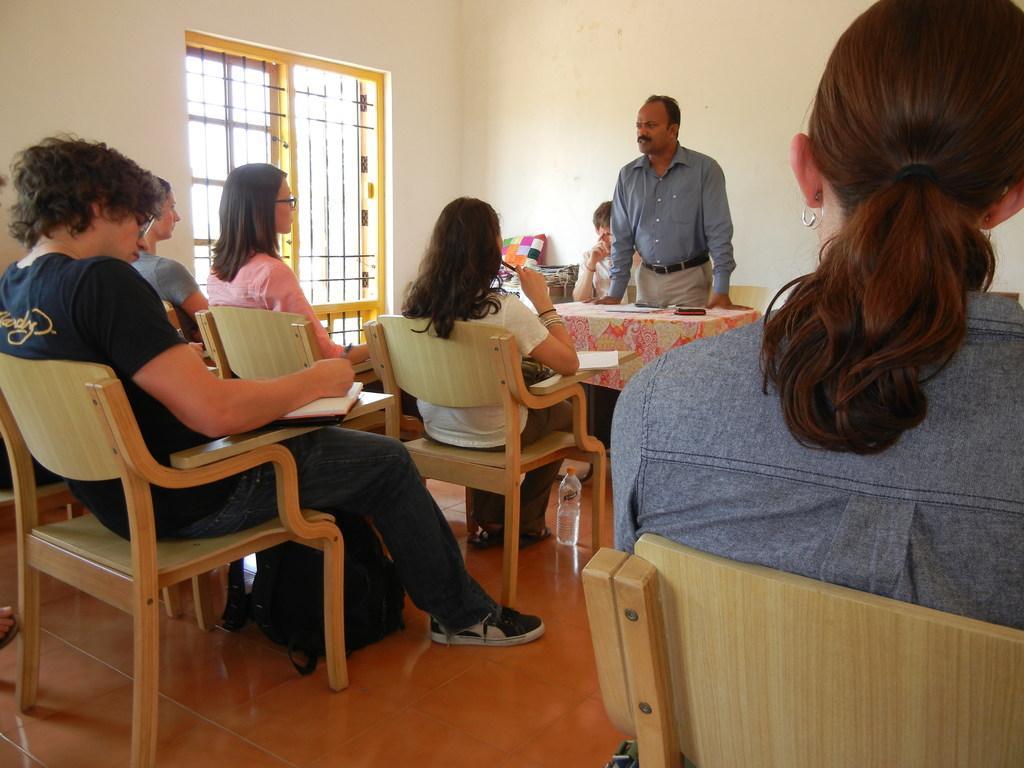Could you give a brief overview of what you see in this image? In this picture there are group of people sitting in the chair , another group of people sitting in the chair and a man standing near the table and at the back ground we have a window. 